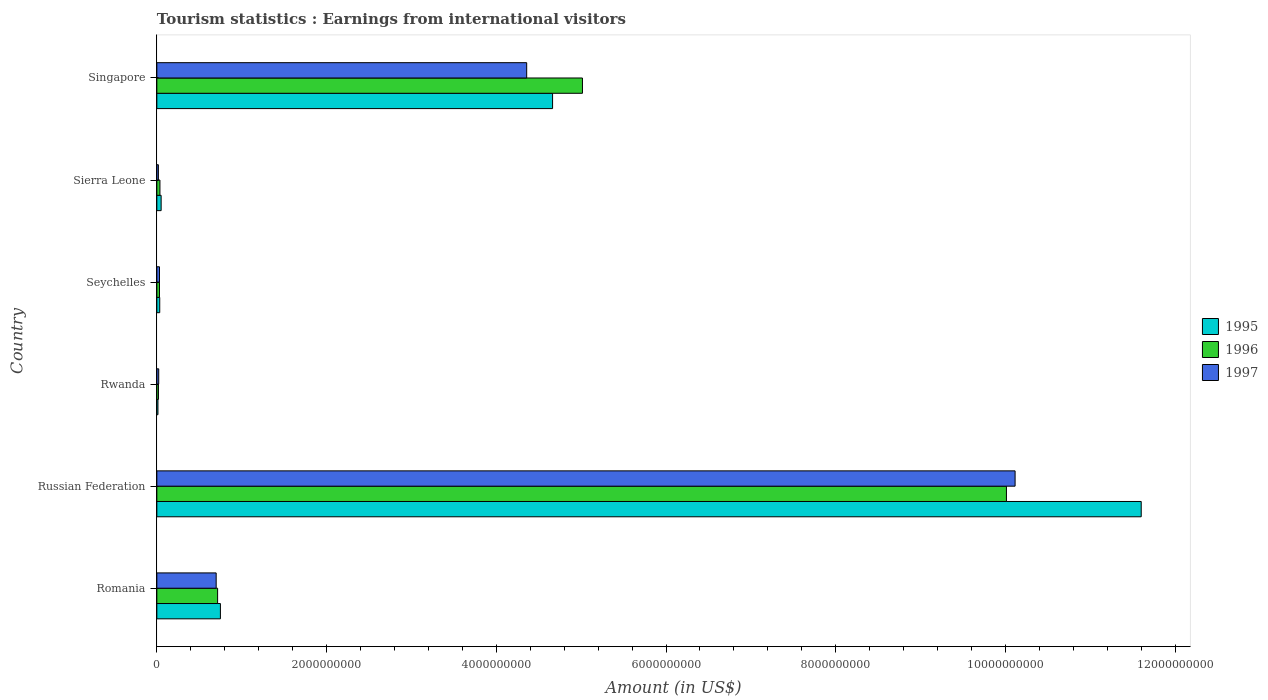How many different coloured bars are there?
Offer a terse response. 3. How many groups of bars are there?
Offer a very short reply. 6. Are the number of bars per tick equal to the number of legend labels?
Offer a terse response. Yes. Are the number of bars on each tick of the Y-axis equal?
Offer a very short reply. Yes. How many bars are there on the 4th tick from the top?
Offer a very short reply. 3. What is the label of the 5th group of bars from the top?
Your response must be concise. Russian Federation. What is the earnings from international visitors in 1995 in Russian Federation?
Make the answer very short. 1.16e+1. Across all countries, what is the maximum earnings from international visitors in 1995?
Provide a short and direct response. 1.16e+1. Across all countries, what is the minimum earnings from international visitors in 1996?
Ensure brevity in your answer.  1.90e+07. In which country was the earnings from international visitors in 1997 maximum?
Provide a succinct answer. Russian Federation. In which country was the earnings from international visitors in 1996 minimum?
Give a very brief answer. Rwanda. What is the total earnings from international visitors in 1995 in the graph?
Your answer should be very brief. 1.71e+1. What is the difference between the earnings from international visitors in 1995 in Seychelles and that in Sierra Leone?
Provide a succinct answer. -1.65e+07. What is the difference between the earnings from international visitors in 1995 in Singapore and the earnings from international visitors in 1996 in Seychelles?
Ensure brevity in your answer.  4.63e+09. What is the average earnings from international visitors in 1995 per country?
Make the answer very short. 2.85e+09. What is the difference between the earnings from international visitors in 1995 and earnings from international visitors in 1997 in Rwanda?
Keep it short and to the point. -9.00e+06. In how many countries, is the earnings from international visitors in 1995 greater than 1200000000 US$?
Your answer should be very brief. 2. What is the ratio of the earnings from international visitors in 1995 in Russian Federation to that in Singapore?
Offer a very short reply. 2.49. What is the difference between the highest and the second highest earnings from international visitors in 1996?
Keep it short and to the point. 5.00e+09. What is the difference between the highest and the lowest earnings from international visitors in 1995?
Your response must be concise. 1.16e+1. In how many countries, is the earnings from international visitors in 1995 greater than the average earnings from international visitors in 1995 taken over all countries?
Give a very brief answer. 2. Is the sum of the earnings from international visitors in 1996 in Romania and Seychelles greater than the maximum earnings from international visitors in 1995 across all countries?
Your answer should be very brief. No. What does the 1st bar from the top in Singapore represents?
Offer a very short reply. 1997. How many countries are there in the graph?
Your answer should be very brief. 6. Are the values on the major ticks of X-axis written in scientific E-notation?
Keep it short and to the point. No. What is the title of the graph?
Keep it short and to the point. Tourism statistics : Earnings from international visitors. Does "1988" appear as one of the legend labels in the graph?
Give a very brief answer. No. What is the Amount (in US$) of 1995 in Romania?
Give a very brief answer. 7.49e+08. What is the Amount (in US$) in 1996 in Romania?
Offer a very short reply. 7.16e+08. What is the Amount (in US$) of 1997 in Romania?
Your answer should be compact. 6.99e+08. What is the Amount (in US$) of 1995 in Russian Federation?
Keep it short and to the point. 1.16e+1. What is the Amount (in US$) of 1996 in Russian Federation?
Keep it short and to the point. 1.00e+1. What is the Amount (in US$) of 1997 in Russian Federation?
Make the answer very short. 1.01e+1. What is the Amount (in US$) of 1995 in Rwanda?
Offer a terse response. 1.30e+07. What is the Amount (in US$) of 1996 in Rwanda?
Your answer should be compact. 1.90e+07. What is the Amount (in US$) in 1997 in Rwanda?
Offer a very short reply. 2.20e+07. What is the Amount (in US$) in 1995 in Seychelles?
Offer a terse response. 3.40e+07. What is the Amount (in US$) in 1996 in Seychelles?
Your response must be concise. 3.10e+07. What is the Amount (in US$) in 1997 in Seychelles?
Provide a succinct answer. 3.10e+07. What is the Amount (in US$) of 1995 in Sierra Leone?
Provide a short and direct response. 5.05e+07. What is the Amount (in US$) in 1996 in Sierra Leone?
Keep it short and to the point. 3.65e+07. What is the Amount (in US$) of 1997 in Sierra Leone?
Offer a terse response. 1.81e+07. What is the Amount (in US$) of 1995 in Singapore?
Ensure brevity in your answer.  4.66e+09. What is the Amount (in US$) in 1996 in Singapore?
Make the answer very short. 5.02e+09. What is the Amount (in US$) of 1997 in Singapore?
Offer a terse response. 4.36e+09. Across all countries, what is the maximum Amount (in US$) of 1995?
Offer a terse response. 1.16e+1. Across all countries, what is the maximum Amount (in US$) in 1996?
Give a very brief answer. 1.00e+1. Across all countries, what is the maximum Amount (in US$) of 1997?
Make the answer very short. 1.01e+1. Across all countries, what is the minimum Amount (in US$) in 1995?
Offer a very short reply. 1.30e+07. Across all countries, what is the minimum Amount (in US$) in 1996?
Make the answer very short. 1.90e+07. Across all countries, what is the minimum Amount (in US$) in 1997?
Provide a short and direct response. 1.81e+07. What is the total Amount (in US$) in 1995 in the graph?
Make the answer very short. 1.71e+1. What is the total Amount (in US$) of 1996 in the graph?
Offer a very short reply. 1.58e+1. What is the total Amount (in US$) in 1997 in the graph?
Keep it short and to the point. 1.52e+1. What is the difference between the Amount (in US$) of 1995 in Romania and that in Russian Federation?
Your answer should be very brief. -1.08e+1. What is the difference between the Amount (in US$) in 1996 in Romania and that in Russian Federation?
Offer a very short reply. -9.30e+09. What is the difference between the Amount (in US$) of 1997 in Romania and that in Russian Federation?
Make the answer very short. -9.41e+09. What is the difference between the Amount (in US$) of 1995 in Romania and that in Rwanda?
Provide a short and direct response. 7.36e+08. What is the difference between the Amount (in US$) in 1996 in Romania and that in Rwanda?
Give a very brief answer. 6.97e+08. What is the difference between the Amount (in US$) in 1997 in Romania and that in Rwanda?
Offer a terse response. 6.77e+08. What is the difference between the Amount (in US$) of 1995 in Romania and that in Seychelles?
Offer a very short reply. 7.15e+08. What is the difference between the Amount (in US$) of 1996 in Romania and that in Seychelles?
Keep it short and to the point. 6.85e+08. What is the difference between the Amount (in US$) of 1997 in Romania and that in Seychelles?
Offer a very short reply. 6.68e+08. What is the difference between the Amount (in US$) of 1995 in Romania and that in Sierra Leone?
Make the answer very short. 6.98e+08. What is the difference between the Amount (in US$) of 1996 in Romania and that in Sierra Leone?
Make the answer very short. 6.80e+08. What is the difference between the Amount (in US$) of 1997 in Romania and that in Sierra Leone?
Your answer should be very brief. 6.81e+08. What is the difference between the Amount (in US$) in 1995 in Romania and that in Singapore?
Offer a very short reply. -3.91e+09. What is the difference between the Amount (in US$) in 1996 in Romania and that in Singapore?
Make the answer very short. -4.30e+09. What is the difference between the Amount (in US$) of 1997 in Romania and that in Singapore?
Ensure brevity in your answer.  -3.66e+09. What is the difference between the Amount (in US$) in 1995 in Russian Federation and that in Rwanda?
Ensure brevity in your answer.  1.16e+1. What is the difference between the Amount (in US$) in 1996 in Russian Federation and that in Rwanda?
Offer a very short reply. 9.99e+09. What is the difference between the Amount (in US$) of 1997 in Russian Federation and that in Rwanda?
Your answer should be very brief. 1.01e+1. What is the difference between the Amount (in US$) of 1995 in Russian Federation and that in Seychelles?
Your answer should be compact. 1.16e+1. What is the difference between the Amount (in US$) in 1996 in Russian Federation and that in Seychelles?
Provide a succinct answer. 9.98e+09. What is the difference between the Amount (in US$) in 1997 in Russian Federation and that in Seychelles?
Offer a very short reply. 1.01e+1. What is the difference between the Amount (in US$) of 1995 in Russian Federation and that in Sierra Leone?
Provide a short and direct response. 1.15e+1. What is the difference between the Amount (in US$) in 1996 in Russian Federation and that in Sierra Leone?
Your response must be concise. 9.97e+09. What is the difference between the Amount (in US$) in 1997 in Russian Federation and that in Sierra Leone?
Provide a succinct answer. 1.01e+1. What is the difference between the Amount (in US$) of 1995 in Russian Federation and that in Singapore?
Give a very brief answer. 6.94e+09. What is the difference between the Amount (in US$) in 1996 in Russian Federation and that in Singapore?
Ensure brevity in your answer.  5.00e+09. What is the difference between the Amount (in US$) in 1997 in Russian Federation and that in Singapore?
Offer a very short reply. 5.76e+09. What is the difference between the Amount (in US$) in 1995 in Rwanda and that in Seychelles?
Your answer should be very brief. -2.10e+07. What is the difference between the Amount (in US$) of 1996 in Rwanda and that in Seychelles?
Provide a succinct answer. -1.20e+07. What is the difference between the Amount (in US$) in 1997 in Rwanda and that in Seychelles?
Give a very brief answer. -9.00e+06. What is the difference between the Amount (in US$) of 1995 in Rwanda and that in Sierra Leone?
Offer a terse response. -3.75e+07. What is the difference between the Amount (in US$) of 1996 in Rwanda and that in Sierra Leone?
Your answer should be very brief. -1.75e+07. What is the difference between the Amount (in US$) in 1997 in Rwanda and that in Sierra Leone?
Keep it short and to the point. 3.90e+06. What is the difference between the Amount (in US$) in 1995 in Rwanda and that in Singapore?
Offer a very short reply. -4.65e+09. What is the difference between the Amount (in US$) in 1996 in Rwanda and that in Singapore?
Give a very brief answer. -5.00e+09. What is the difference between the Amount (in US$) of 1997 in Rwanda and that in Singapore?
Give a very brief answer. -4.34e+09. What is the difference between the Amount (in US$) in 1995 in Seychelles and that in Sierra Leone?
Offer a very short reply. -1.65e+07. What is the difference between the Amount (in US$) of 1996 in Seychelles and that in Sierra Leone?
Ensure brevity in your answer.  -5.50e+06. What is the difference between the Amount (in US$) of 1997 in Seychelles and that in Sierra Leone?
Your answer should be compact. 1.29e+07. What is the difference between the Amount (in US$) of 1995 in Seychelles and that in Singapore?
Offer a very short reply. -4.63e+09. What is the difference between the Amount (in US$) of 1996 in Seychelles and that in Singapore?
Your response must be concise. -4.98e+09. What is the difference between the Amount (in US$) in 1997 in Seychelles and that in Singapore?
Your response must be concise. -4.33e+09. What is the difference between the Amount (in US$) in 1995 in Sierra Leone and that in Singapore?
Make the answer very short. -4.61e+09. What is the difference between the Amount (in US$) of 1996 in Sierra Leone and that in Singapore?
Your answer should be compact. -4.98e+09. What is the difference between the Amount (in US$) of 1997 in Sierra Leone and that in Singapore?
Your answer should be very brief. -4.34e+09. What is the difference between the Amount (in US$) in 1995 in Romania and the Amount (in US$) in 1996 in Russian Federation?
Offer a very short reply. -9.26e+09. What is the difference between the Amount (in US$) in 1995 in Romania and the Amount (in US$) in 1997 in Russian Federation?
Provide a succinct answer. -9.36e+09. What is the difference between the Amount (in US$) in 1996 in Romania and the Amount (in US$) in 1997 in Russian Federation?
Keep it short and to the point. -9.40e+09. What is the difference between the Amount (in US$) in 1995 in Romania and the Amount (in US$) in 1996 in Rwanda?
Keep it short and to the point. 7.30e+08. What is the difference between the Amount (in US$) in 1995 in Romania and the Amount (in US$) in 1997 in Rwanda?
Your response must be concise. 7.27e+08. What is the difference between the Amount (in US$) of 1996 in Romania and the Amount (in US$) of 1997 in Rwanda?
Make the answer very short. 6.94e+08. What is the difference between the Amount (in US$) in 1995 in Romania and the Amount (in US$) in 1996 in Seychelles?
Your answer should be compact. 7.18e+08. What is the difference between the Amount (in US$) in 1995 in Romania and the Amount (in US$) in 1997 in Seychelles?
Ensure brevity in your answer.  7.18e+08. What is the difference between the Amount (in US$) in 1996 in Romania and the Amount (in US$) in 1997 in Seychelles?
Ensure brevity in your answer.  6.85e+08. What is the difference between the Amount (in US$) of 1995 in Romania and the Amount (in US$) of 1996 in Sierra Leone?
Give a very brief answer. 7.12e+08. What is the difference between the Amount (in US$) of 1995 in Romania and the Amount (in US$) of 1997 in Sierra Leone?
Keep it short and to the point. 7.31e+08. What is the difference between the Amount (in US$) of 1996 in Romania and the Amount (in US$) of 1997 in Sierra Leone?
Offer a terse response. 6.98e+08. What is the difference between the Amount (in US$) of 1995 in Romania and the Amount (in US$) of 1996 in Singapore?
Give a very brief answer. -4.27e+09. What is the difference between the Amount (in US$) of 1995 in Romania and the Amount (in US$) of 1997 in Singapore?
Ensure brevity in your answer.  -3.61e+09. What is the difference between the Amount (in US$) in 1996 in Romania and the Amount (in US$) in 1997 in Singapore?
Give a very brief answer. -3.64e+09. What is the difference between the Amount (in US$) of 1995 in Russian Federation and the Amount (in US$) of 1996 in Rwanda?
Offer a very short reply. 1.16e+1. What is the difference between the Amount (in US$) of 1995 in Russian Federation and the Amount (in US$) of 1997 in Rwanda?
Ensure brevity in your answer.  1.16e+1. What is the difference between the Amount (in US$) in 1996 in Russian Federation and the Amount (in US$) in 1997 in Rwanda?
Your answer should be very brief. 9.99e+09. What is the difference between the Amount (in US$) of 1995 in Russian Federation and the Amount (in US$) of 1996 in Seychelles?
Offer a very short reply. 1.16e+1. What is the difference between the Amount (in US$) of 1995 in Russian Federation and the Amount (in US$) of 1997 in Seychelles?
Your answer should be compact. 1.16e+1. What is the difference between the Amount (in US$) in 1996 in Russian Federation and the Amount (in US$) in 1997 in Seychelles?
Give a very brief answer. 9.98e+09. What is the difference between the Amount (in US$) in 1995 in Russian Federation and the Amount (in US$) in 1996 in Sierra Leone?
Provide a short and direct response. 1.16e+1. What is the difference between the Amount (in US$) in 1995 in Russian Federation and the Amount (in US$) in 1997 in Sierra Leone?
Your response must be concise. 1.16e+1. What is the difference between the Amount (in US$) in 1996 in Russian Federation and the Amount (in US$) in 1997 in Sierra Leone?
Your answer should be very brief. 9.99e+09. What is the difference between the Amount (in US$) in 1995 in Russian Federation and the Amount (in US$) in 1996 in Singapore?
Provide a succinct answer. 6.58e+09. What is the difference between the Amount (in US$) of 1995 in Russian Federation and the Amount (in US$) of 1997 in Singapore?
Give a very brief answer. 7.24e+09. What is the difference between the Amount (in US$) in 1996 in Russian Federation and the Amount (in US$) in 1997 in Singapore?
Offer a terse response. 5.65e+09. What is the difference between the Amount (in US$) of 1995 in Rwanda and the Amount (in US$) of 1996 in Seychelles?
Your answer should be very brief. -1.80e+07. What is the difference between the Amount (in US$) in 1995 in Rwanda and the Amount (in US$) in 1997 in Seychelles?
Offer a terse response. -1.80e+07. What is the difference between the Amount (in US$) of 1996 in Rwanda and the Amount (in US$) of 1997 in Seychelles?
Offer a very short reply. -1.20e+07. What is the difference between the Amount (in US$) in 1995 in Rwanda and the Amount (in US$) in 1996 in Sierra Leone?
Offer a terse response. -2.35e+07. What is the difference between the Amount (in US$) of 1995 in Rwanda and the Amount (in US$) of 1997 in Sierra Leone?
Keep it short and to the point. -5.10e+06. What is the difference between the Amount (in US$) of 1996 in Rwanda and the Amount (in US$) of 1997 in Sierra Leone?
Provide a short and direct response. 9.00e+05. What is the difference between the Amount (in US$) in 1995 in Rwanda and the Amount (in US$) in 1996 in Singapore?
Provide a short and direct response. -5.00e+09. What is the difference between the Amount (in US$) of 1995 in Rwanda and the Amount (in US$) of 1997 in Singapore?
Keep it short and to the point. -4.34e+09. What is the difference between the Amount (in US$) of 1996 in Rwanda and the Amount (in US$) of 1997 in Singapore?
Provide a succinct answer. -4.34e+09. What is the difference between the Amount (in US$) in 1995 in Seychelles and the Amount (in US$) in 1996 in Sierra Leone?
Offer a very short reply. -2.50e+06. What is the difference between the Amount (in US$) in 1995 in Seychelles and the Amount (in US$) in 1997 in Sierra Leone?
Ensure brevity in your answer.  1.59e+07. What is the difference between the Amount (in US$) of 1996 in Seychelles and the Amount (in US$) of 1997 in Sierra Leone?
Give a very brief answer. 1.29e+07. What is the difference between the Amount (in US$) in 1995 in Seychelles and the Amount (in US$) in 1996 in Singapore?
Ensure brevity in your answer.  -4.98e+09. What is the difference between the Amount (in US$) of 1995 in Seychelles and the Amount (in US$) of 1997 in Singapore?
Provide a short and direct response. -4.32e+09. What is the difference between the Amount (in US$) in 1996 in Seychelles and the Amount (in US$) in 1997 in Singapore?
Offer a very short reply. -4.33e+09. What is the difference between the Amount (in US$) of 1995 in Sierra Leone and the Amount (in US$) of 1996 in Singapore?
Ensure brevity in your answer.  -4.96e+09. What is the difference between the Amount (in US$) of 1995 in Sierra Leone and the Amount (in US$) of 1997 in Singapore?
Keep it short and to the point. -4.31e+09. What is the difference between the Amount (in US$) in 1996 in Sierra Leone and the Amount (in US$) in 1997 in Singapore?
Offer a very short reply. -4.32e+09. What is the average Amount (in US$) of 1995 per country?
Ensure brevity in your answer.  2.85e+09. What is the average Amount (in US$) in 1996 per country?
Keep it short and to the point. 2.64e+09. What is the average Amount (in US$) in 1997 per country?
Offer a terse response. 2.54e+09. What is the difference between the Amount (in US$) in 1995 and Amount (in US$) in 1996 in Romania?
Provide a succinct answer. 3.30e+07. What is the difference between the Amount (in US$) in 1995 and Amount (in US$) in 1997 in Romania?
Provide a succinct answer. 5.00e+07. What is the difference between the Amount (in US$) of 1996 and Amount (in US$) of 1997 in Romania?
Provide a succinct answer. 1.70e+07. What is the difference between the Amount (in US$) of 1995 and Amount (in US$) of 1996 in Russian Federation?
Keep it short and to the point. 1.59e+09. What is the difference between the Amount (in US$) of 1995 and Amount (in US$) of 1997 in Russian Federation?
Ensure brevity in your answer.  1.49e+09. What is the difference between the Amount (in US$) in 1996 and Amount (in US$) in 1997 in Russian Federation?
Your answer should be very brief. -1.02e+08. What is the difference between the Amount (in US$) of 1995 and Amount (in US$) of 1996 in Rwanda?
Ensure brevity in your answer.  -6.00e+06. What is the difference between the Amount (in US$) of 1995 and Amount (in US$) of 1997 in Rwanda?
Make the answer very short. -9.00e+06. What is the difference between the Amount (in US$) of 1996 and Amount (in US$) of 1997 in Rwanda?
Your answer should be compact. -3.00e+06. What is the difference between the Amount (in US$) of 1995 and Amount (in US$) of 1996 in Seychelles?
Offer a very short reply. 3.00e+06. What is the difference between the Amount (in US$) in 1995 and Amount (in US$) in 1997 in Seychelles?
Provide a short and direct response. 3.00e+06. What is the difference between the Amount (in US$) of 1996 and Amount (in US$) of 1997 in Seychelles?
Ensure brevity in your answer.  0. What is the difference between the Amount (in US$) of 1995 and Amount (in US$) of 1996 in Sierra Leone?
Ensure brevity in your answer.  1.40e+07. What is the difference between the Amount (in US$) in 1995 and Amount (in US$) in 1997 in Sierra Leone?
Keep it short and to the point. 3.24e+07. What is the difference between the Amount (in US$) of 1996 and Amount (in US$) of 1997 in Sierra Leone?
Ensure brevity in your answer.  1.84e+07. What is the difference between the Amount (in US$) in 1995 and Amount (in US$) in 1996 in Singapore?
Offer a terse response. -3.52e+08. What is the difference between the Amount (in US$) in 1995 and Amount (in US$) in 1997 in Singapore?
Provide a short and direct response. 3.05e+08. What is the difference between the Amount (in US$) of 1996 and Amount (in US$) of 1997 in Singapore?
Provide a succinct answer. 6.57e+08. What is the ratio of the Amount (in US$) of 1995 in Romania to that in Russian Federation?
Make the answer very short. 0.06. What is the ratio of the Amount (in US$) of 1996 in Romania to that in Russian Federation?
Offer a terse response. 0.07. What is the ratio of the Amount (in US$) in 1997 in Romania to that in Russian Federation?
Your response must be concise. 0.07. What is the ratio of the Amount (in US$) in 1995 in Romania to that in Rwanda?
Your answer should be compact. 57.62. What is the ratio of the Amount (in US$) of 1996 in Romania to that in Rwanda?
Make the answer very short. 37.68. What is the ratio of the Amount (in US$) of 1997 in Romania to that in Rwanda?
Offer a very short reply. 31.77. What is the ratio of the Amount (in US$) of 1995 in Romania to that in Seychelles?
Keep it short and to the point. 22.03. What is the ratio of the Amount (in US$) of 1996 in Romania to that in Seychelles?
Provide a succinct answer. 23.1. What is the ratio of the Amount (in US$) of 1997 in Romania to that in Seychelles?
Your answer should be compact. 22.55. What is the ratio of the Amount (in US$) in 1995 in Romania to that in Sierra Leone?
Offer a terse response. 14.83. What is the ratio of the Amount (in US$) of 1996 in Romania to that in Sierra Leone?
Keep it short and to the point. 19.62. What is the ratio of the Amount (in US$) in 1997 in Romania to that in Sierra Leone?
Offer a terse response. 38.62. What is the ratio of the Amount (in US$) in 1995 in Romania to that in Singapore?
Make the answer very short. 0.16. What is the ratio of the Amount (in US$) in 1996 in Romania to that in Singapore?
Offer a terse response. 0.14. What is the ratio of the Amount (in US$) of 1997 in Romania to that in Singapore?
Ensure brevity in your answer.  0.16. What is the ratio of the Amount (in US$) in 1995 in Russian Federation to that in Rwanda?
Your answer should be very brief. 892.23. What is the ratio of the Amount (in US$) of 1996 in Russian Federation to that in Rwanda?
Offer a terse response. 526.89. What is the ratio of the Amount (in US$) in 1997 in Russian Federation to that in Rwanda?
Provide a succinct answer. 459.68. What is the ratio of the Amount (in US$) of 1995 in Russian Federation to that in Seychelles?
Your answer should be very brief. 341.15. What is the ratio of the Amount (in US$) in 1996 in Russian Federation to that in Seychelles?
Provide a short and direct response. 322.94. What is the ratio of the Amount (in US$) in 1997 in Russian Federation to that in Seychelles?
Offer a terse response. 326.23. What is the ratio of the Amount (in US$) in 1995 in Russian Federation to that in Sierra Leone?
Ensure brevity in your answer.  229.68. What is the ratio of the Amount (in US$) of 1996 in Russian Federation to that in Sierra Leone?
Offer a terse response. 274.27. What is the ratio of the Amount (in US$) in 1997 in Russian Federation to that in Sierra Leone?
Provide a short and direct response. 558.73. What is the ratio of the Amount (in US$) of 1995 in Russian Federation to that in Singapore?
Ensure brevity in your answer.  2.49. What is the ratio of the Amount (in US$) of 1996 in Russian Federation to that in Singapore?
Give a very brief answer. 2. What is the ratio of the Amount (in US$) in 1997 in Russian Federation to that in Singapore?
Offer a very short reply. 2.32. What is the ratio of the Amount (in US$) of 1995 in Rwanda to that in Seychelles?
Make the answer very short. 0.38. What is the ratio of the Amount (in US$) in 1996 in Rwanda to that in Seychelles?
Give a very brief answer. 0.61. What is the ratio of the Amount (in US$) in 1997 in Rwanda to that in Seychelles?
Provide a succinct answer. 0.71. What is the ratio of the Amount (in US$) of 1995 in Rwanda to that in Sierra Leone?
Keep it short and to the point. 0.26. What is the ratio of the Amount (in US$) of 1996 in Rwanda to that in Sierra Leone?
Provide a short and direct response. 0.52. What is the ratio of the Amount (in US$) in 1997 in Rwanda to that in Sierra Leone?
Offer a very short reply. 1.22. What is the ratio of the Amount (in US$) in 1995 in Rwanda to that in Singapore?
Your response must be concise. 0. What is the ratio of the Amount (in US$) of 1996 in Rwanda to that in Singapore?
Your answer should be compact. 0. What is the ratio of the Amount (in US$) of 1997 in Rwanda to that in Singapore?
Your answer should be compact. 0.01. What is the ratio of the Amount (in US$) of 1995 in Seychelles to that in Sierra Leone?
Your response must be concise. 0.67. What is the ratio of the Amount (in US$) of 1996 in Seychelles to that in Sierra Leone?
Your answer should be very brief. 0.85. What is the ratio of the Amount (in US$) in 1997 in Seychelles to that in Sierra Leone?
Keep it short and to the point. 1.71. What is the ratio of the Amount (in US$) in 1995 in Seychelles to that in Singapore?
Your answer should be compact. 0.01. What is the ratio of the Amount (in US$) of 1996 in Seychelles to that in Singapore?
Keep it short and to the point. 0.01. What is the ratio of the Amount (in US$) in 1997 in Seychelles to that in Singapore?
Ensure brevity in your answer.  0.01. What is the ratio of the Amount (in US$) in 1995 in Sierra Leone to that in Singapore?
Keep it short and to the point. 0.01. What is the ratio of the Amount (in US$) of 1996 in Sierra Leone to that in Singapore?
Ensure brevity in your answer.  0.01. What is the ratio of the Amount (in US$) of 1997 in Sierra Leone to that in Singapore?
Offer a very short reply. 0. What is the difference between the highest and the second highest Amount (in US$) in 1995?
Make the answer very short. 6.94e+09. What is the difference between the highest and the second highest Amount (in US$) of 1996?
Your answer should be compact. 5.00e+09. What is the difference between the highest and the second highest Amount (in US$) in 1997?
Your answer should be compact. 5.76e+09. What is the difference between the highest and the lowest Amount (in US$) in 1995?
Keep it short and to the point. 1.16e+1. What is the difference between the highest and the lowest Amount (in US$) in 1996?
Your response must be concise. 9.99e+09. What is the difference between the highest and the lowest Amount (in US$) of 1997?
Ensure brevity in your answer.  1.01e+1. 